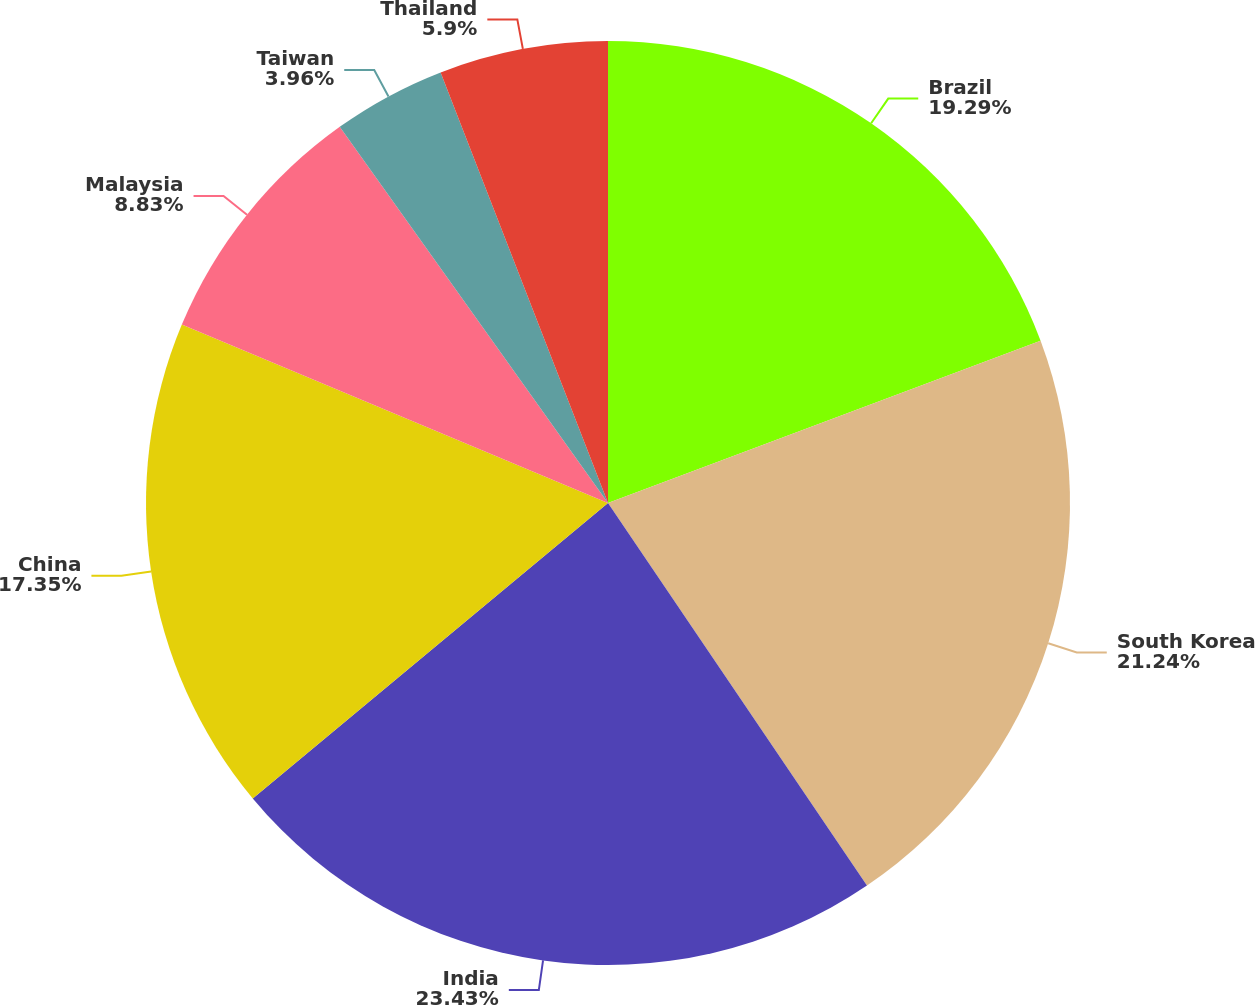Convert chart to OTSL. <chart><loc_0><loc_0><loc_500><loc_500><pie_chart><fcel>Brazil<fcel>South Korea<fcel>India<fcel>China<fcel>Malaysia<fcel>Taiwan<fcel>Thailand<nl><fcel>19.29%<fcel>21.24%<fcel>23.43%<fcel>17.35%<fcel>8.83%<fcel>3.96%<fcel>5.9%<nl></chart> 